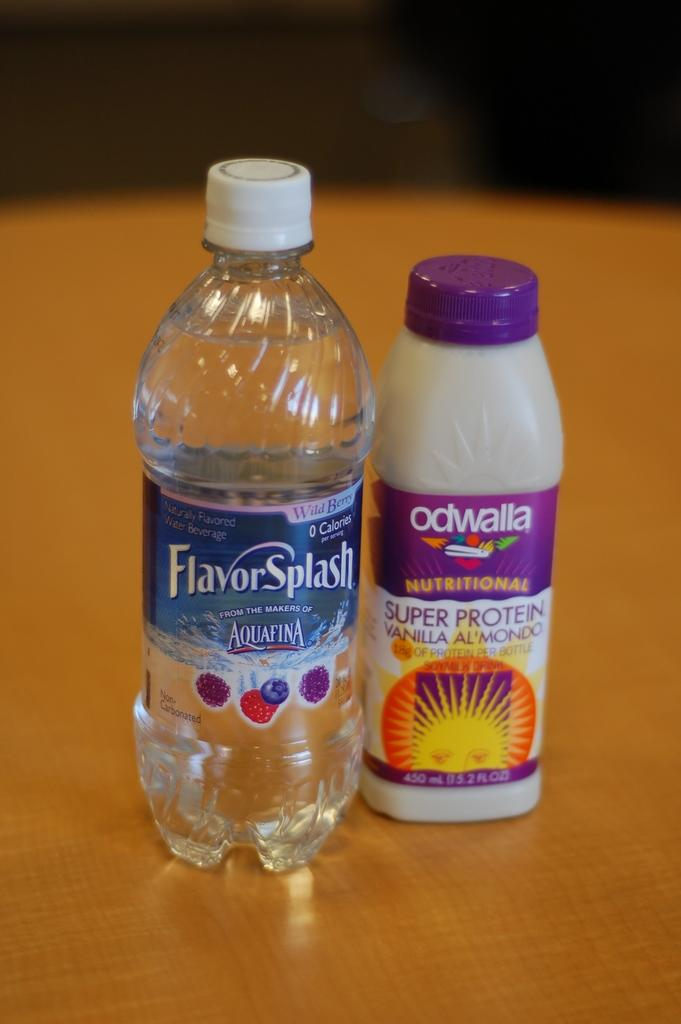<image>
Summarize the visual content of the image. Bottles of Aquafina and Odwalla sit next to each other. 